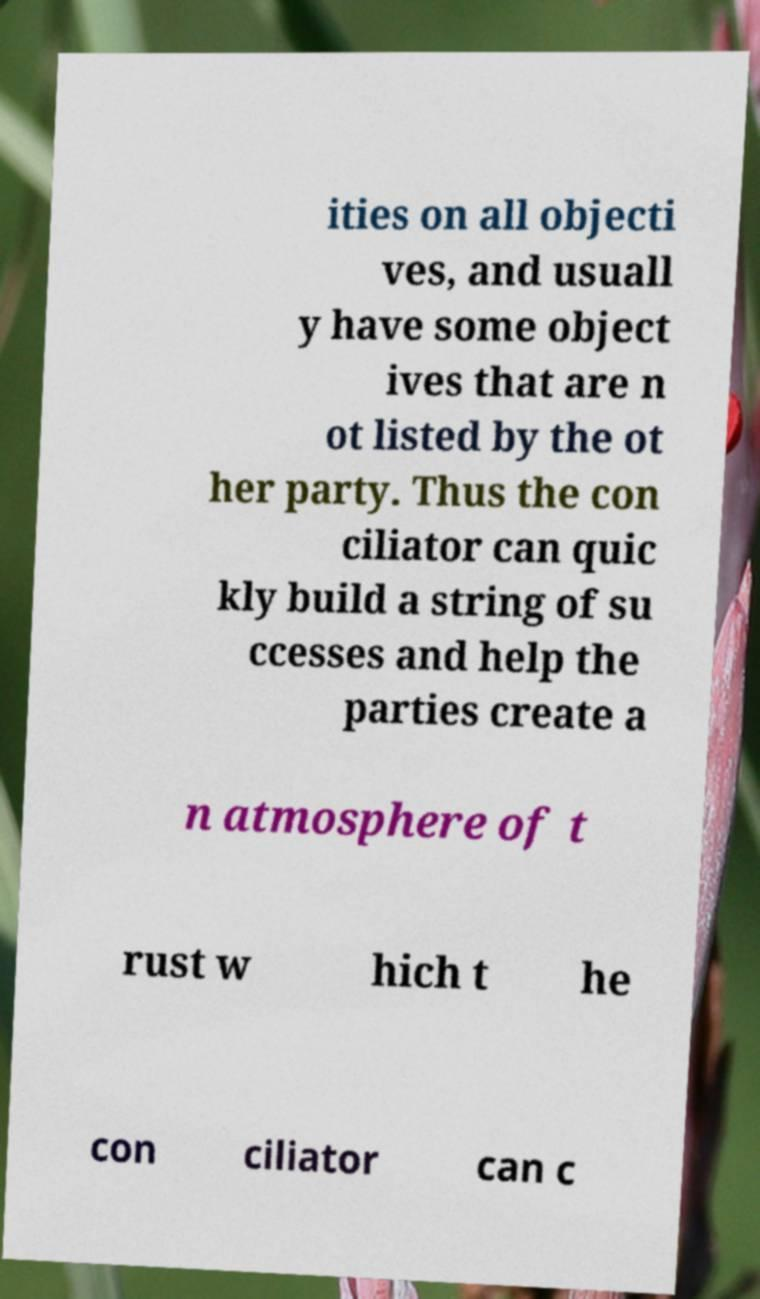Can you accurately transcribe the text from the provided image for me? ities on all objecti ves, and usuall y have some object ives that are n ot listed by the ot her party. Thus the con ciliator can quic kly build a string of su ccesses and help the parties create a n atmosphere of t rust w hich t he con ciliator can c 